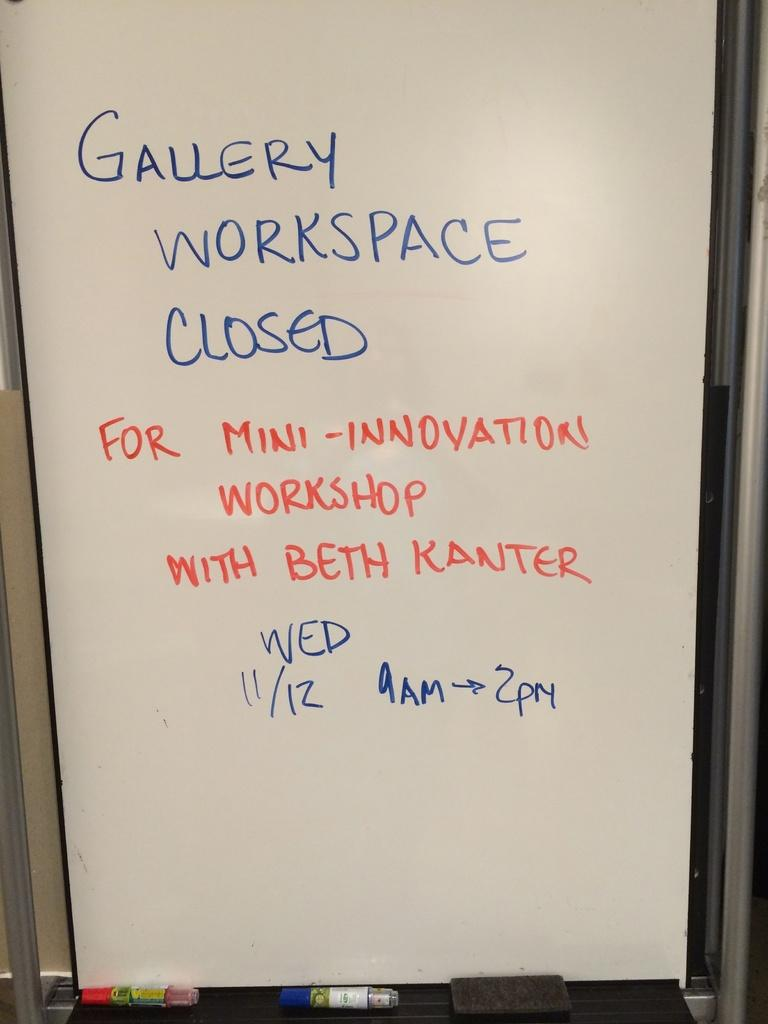<image>
Provide a brief description of the given image. A white board with writing in red and blue ink is advising of the gallery workspace being closed. 